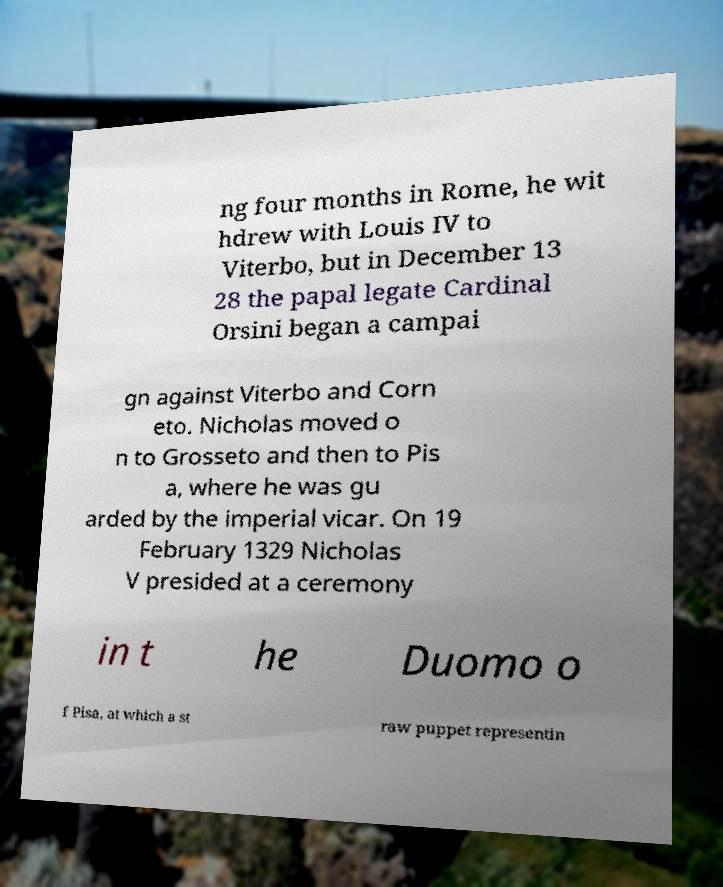Can you accurately transcribe the text from the provided image for me? ng four months in Rome, he wit hdrew with Louis IV to Viterbo, but in December 13 28 the papal legate Cardinal Orsini began a campai gn against Viterbo and Corn eto. Nicholas moved o n to Grosseto and then to Pis a, where he was gu arded by the imperial vicar. On 19 February 1329 Nicholas V presided at a ceremony in t he Duomo o f Pisa, at which a st raw puppet representin 